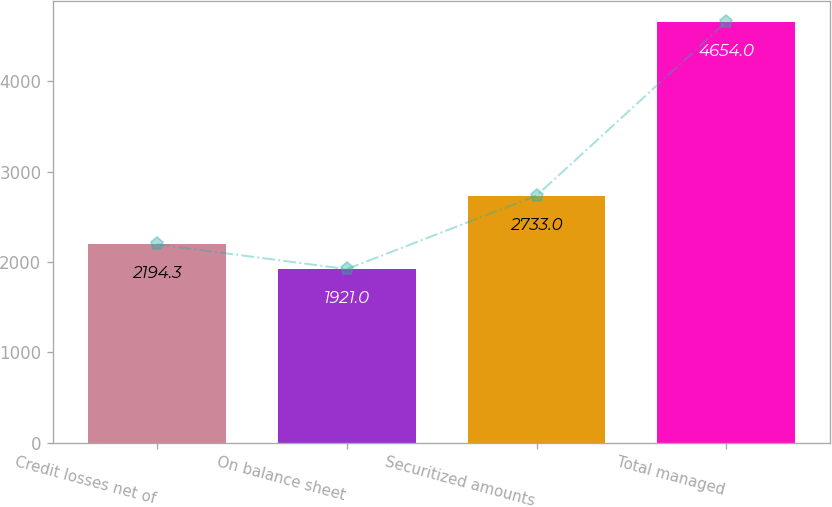Convert chart. <chart><loc_0><loc_0><loc_500><loc_500><bar_chart><fcel>Credit losses net of<fcel>On balance sheet<fcel>Securitized amounts<fcel>Total managed<nl><fcel>2194.3<fcel>1921<fcel>2733<fcel>4654<nl></chart> 